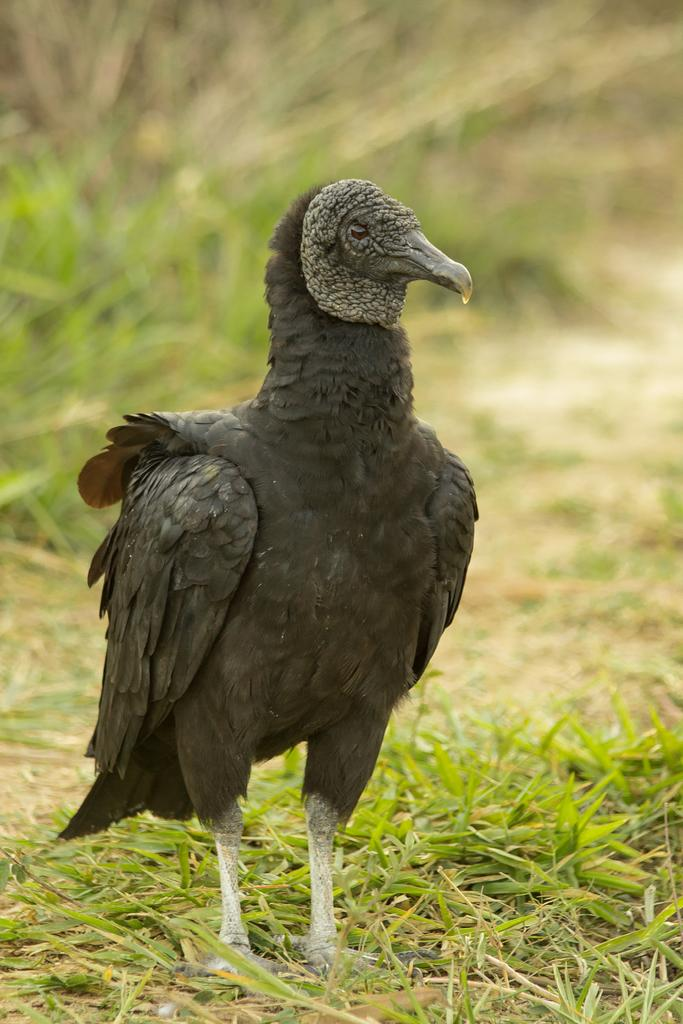What type of bird is in the image? There is a vulture in the image. Where is the vulture located? The vulture is on the grass. Can you describe the background of the image? The background of the image is blurred. What type of glue is the vulture using to stick the sweater to the wool in the image? There is no glue, sweater, or wool present in the image. The image only features a vulture on the grass with a blurred background. 